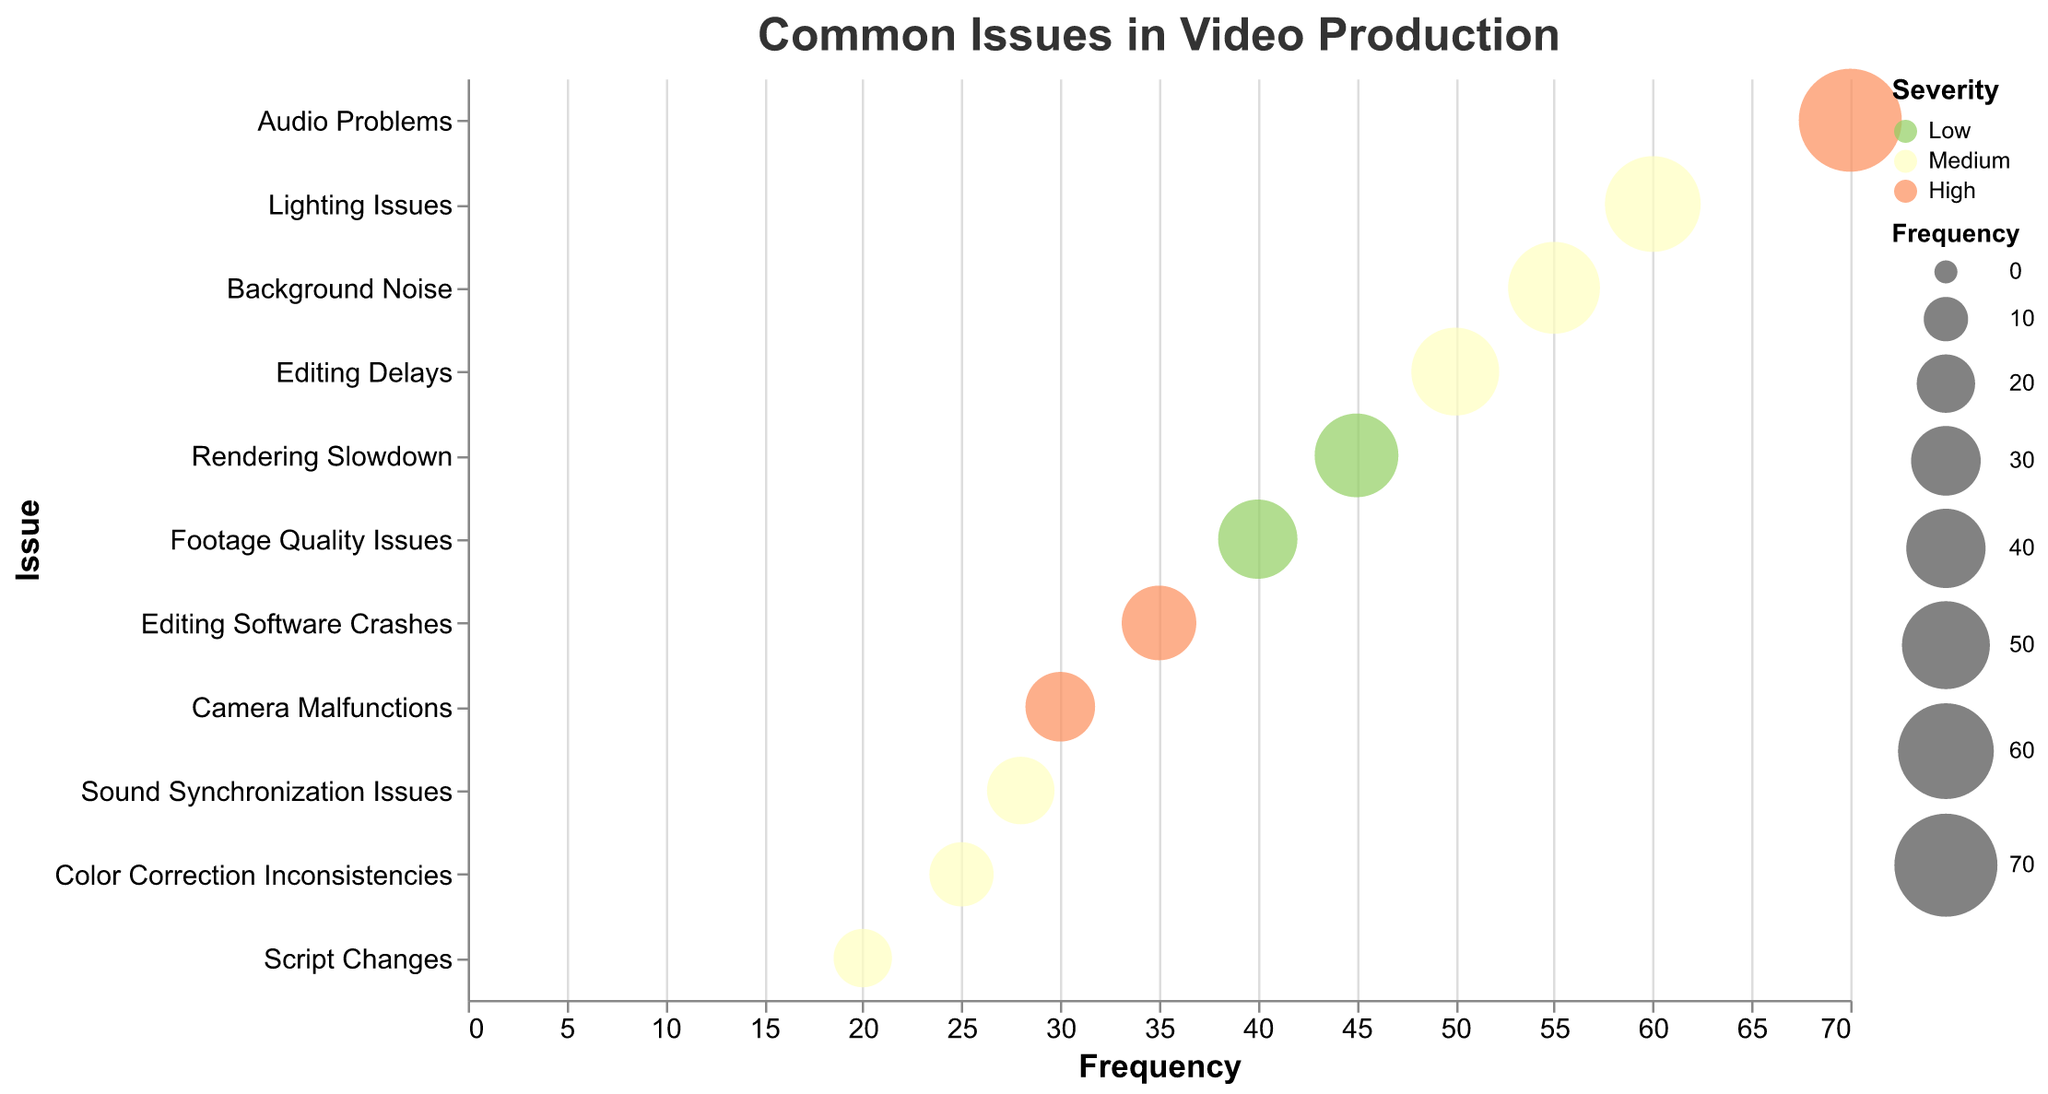What is the most frequent issue in video production according to the chart? The chart shows the frequency of issues on the x-axis. The bubble farthest to the right, which corresponds to the highest frequency, represents "Audio Problems" with a frequency of 70.
Answer: Audio Problems Which issue has the highest severity but a lower frequency than audio problems? The color of the bubbles indicates severity, with red representing "High" severity. Among the high severity issues, "Camera Malfunctions" has a lower frequency (30) compared to "Audio Problems".
Answer: Camera Malfunctions Among medium severity issues, which one has the second highest frequency? The bubbles colored in yellow represent medium severity. Sorting these by frequency, "Lighting Issues" has the highest frequency at 60, followed by "Background Noise" at 55. Therefore, "Background Noise" has the second highest frequency among medium severity issues.
Answer: Background Noise How does the frequency of color correction inconsistencies compare to rendering slowdown? The frequency of "Color Correction Inconsistencies" is 25, while "Rendering Slowdown" has a frequency of 45. By comparing these values, we see that "Rendering Slowdown" has a higher frequency than "Color Correction Inconsistencies".
Answer: Rendering Slowdown is more frequent What is the average frequency of the issues with high severity? The high severity issues are "Audio Problems" (70), "Camera Malfunctions" (30), and "Editing Software Crashes" (35). The average is calculated as (70 + 30 + 35) / 3 = 135 / 3 = 45.
Answer: 45 Based on the chart, which issue is both of medium severity and has a frequency less than 30? By identifying the bubbles with medium severity (yellow) and a frequency less than 30, "Sound Synchronization Issues" has a frequency of 28 and meets both criteria.
Answer: Sound Synchronization Issues How many issues are categorized as low severity? The low severity bubbles are colored in green. There are two such issues: "Footage Quality Issues" and "Rendering Slowdown".
Answer: 2 Which issue appears to have a similar frequency to audio problems but different severity? No issue has a frequency that matches or is close to "Audio Problems" (70) and a different severity. The bubbles are distinct in terms of frequency and severity categories.
Answer: None What is the color code for the bubbles representing medium severity? Bubbles representing medium severity are colored in yellow.
Answer: Yellow What's the difference in frequency between the most and least frequent issues? The most frequent issue is "Audio Problems" with a frequency of 70, while the least frequent issue is "Script Changes" with a frequency of 20. The difference is calculated as 70 - 20 = 50.
Answer: 50 